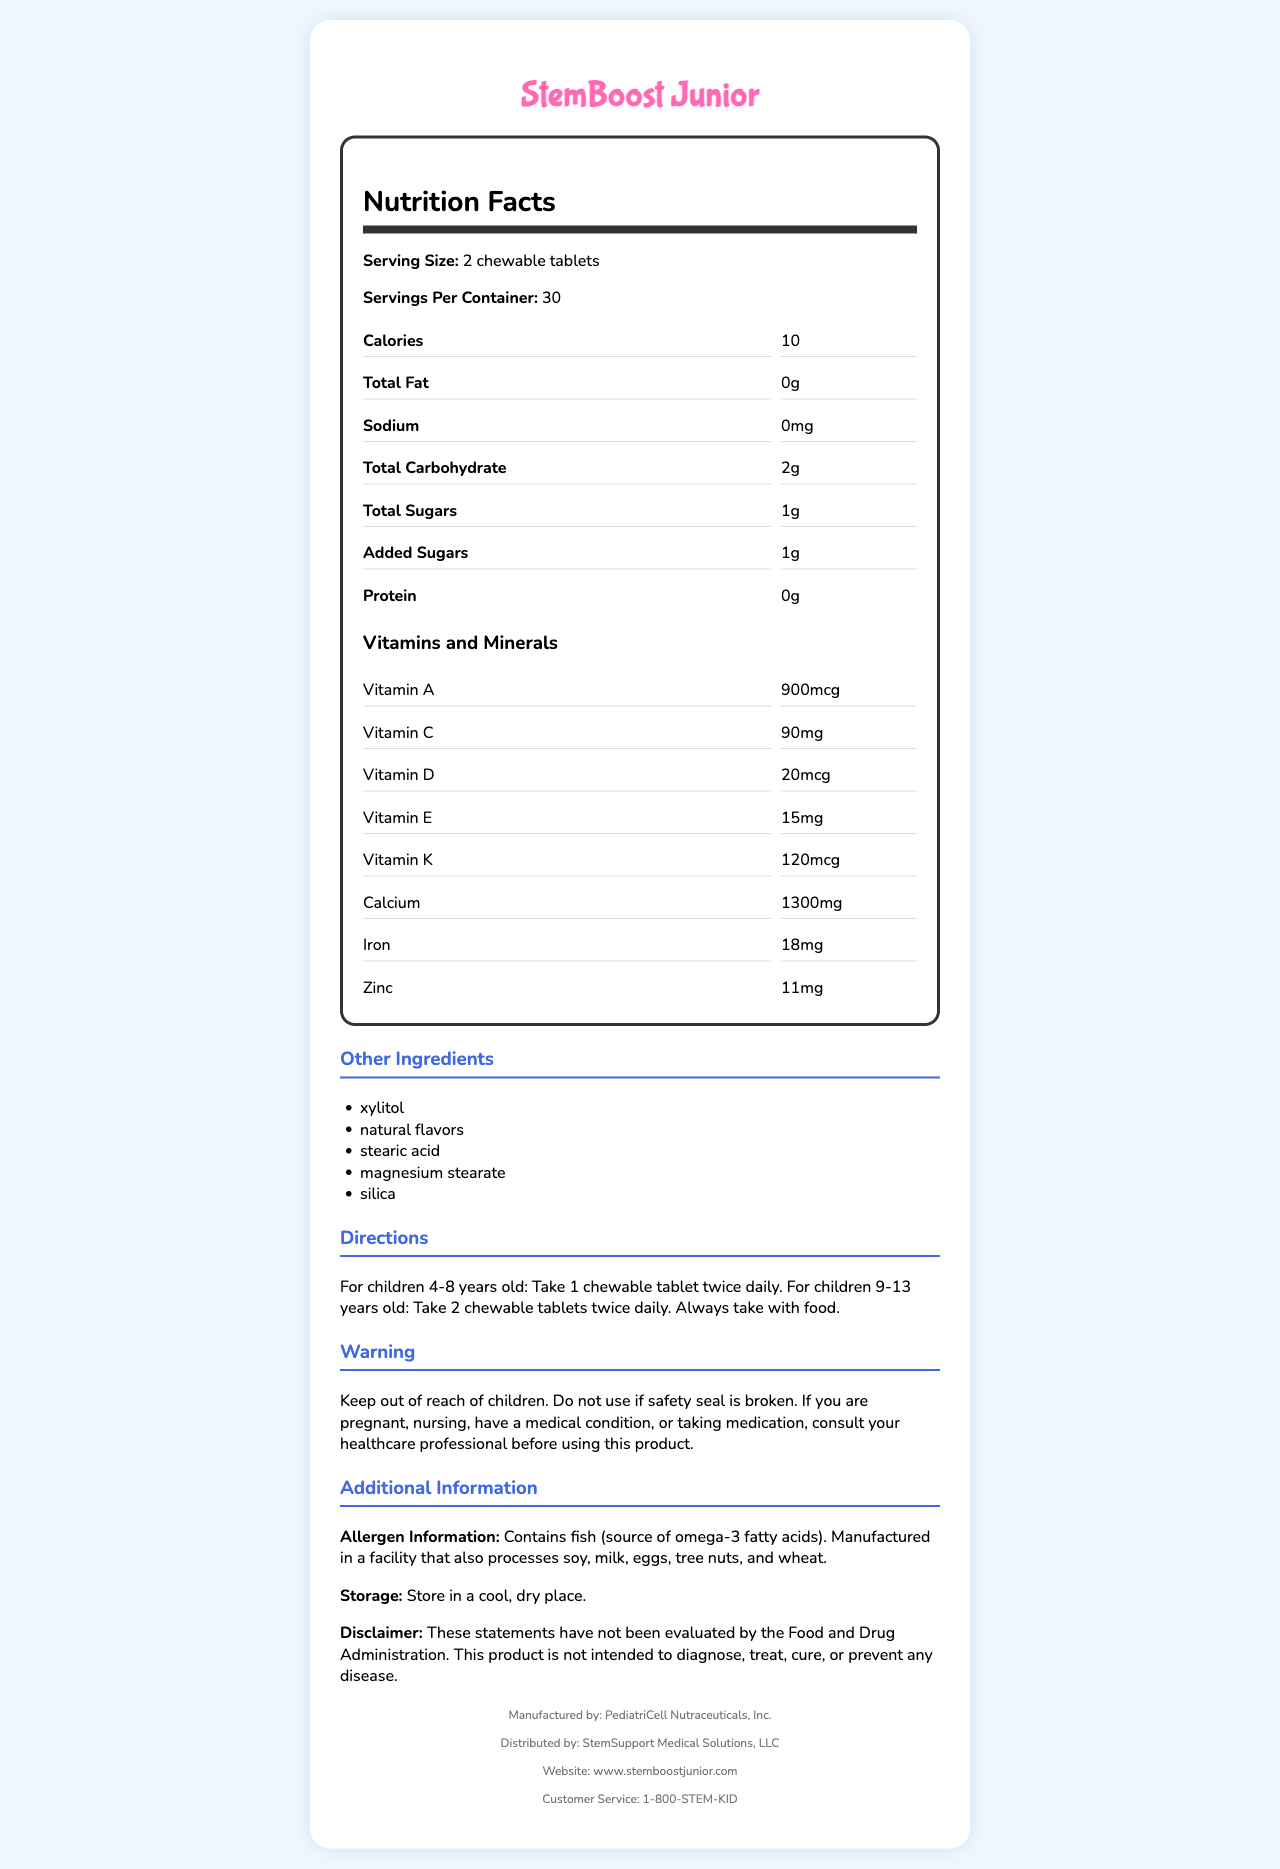what is the serving size for StemBoost Junior? The serving size is clearly stated as "2 chewable tablets" in the Nutrition Facts section.
Answer: 2 chewable tablets how many calories are in one serving of StemBoost Junior? The document specifies that there are 10 calories per serving.
Answer: 10 what age groups are provided with specific dosage directions? The Directions section specifies dosages for children 4-8 years old and children 9-13 years old.
Answer: Children 4-8 years old and children 9-13 years old what should you do if the safety seal is broken? The Warning section advises not to use the product if the safety seal is broken.
Answer: Do not use it how many servings are there per container? The Nutrition Facts section states that there are 30 servings per container.
Answer: 30 which of the following vitamins is included in StemBoost Junior? A. Vitamin H B. Vitamin K C. Vitamin X The Nutrition Facts section lists Vitamin K as one of the included vitamins.
Answer: B how much omega-3 fatty acids are in each serving? A. 50mg B. 100mg C. 200mg D. 150mg The document lists omega-3 fatty acids as containing 100mg per serving.
Answer: B is this product safe for children under 4 years old? The Directions section only provides guidelines for children 4-8 years old and 9-13 years old, implying it is not intended for children under 4 years old.
Answer: No does the product contain any allergens? The Allergen Information section states that the product contains fish and is manufactured in a facility that processes soy, milk, eggs, tree nuts, and wheat.
Answer: Yes summarize the main purpose of the document The document gives a comprehensive overview of the product "StemBoost Junior," including its nutritional content, serving size, dosage instructions, allergen information, warnings, and storage instructions.
Answer: Provide detailed nutrition facts and usage information for StemBoost Junior what is the source of omega-3 fatty acids in this supplement? The Allergen Information mentions that omega-3 fatty acids come from fish.
Answer: Fish is the product intended to diagnose, treat, cure, or prevent any disease? The Disclaimer explicitly states that the product is not intended to diagnose, treat, cure, or prevent any disease.
Answer: No how should the product be stored? The Storage section advises to store the product in a cool, dry place.
Answer: Store in a cool, dry place what are the main active ingredients in StemBoost Junior? The Nutrition Facts and Ingredients sections list vitamins, minerals, omega-3 fatty acids, L-carnitine, coenzyme Q10, inositol, and choline as main active ingredients.
Answer: Vitamins, minerals, omega-3 fatty acids, L-carnitine, coenzyme Q10, inositol, choline how should you take the tablets? The Directions section states that the tablets should always be taken with food.
Answer: Always take with food how do the vitamin D levels in StemBoost Junior compare to other children's supplements? The document does not provide any comparison with other children's supplements.
Answer: Cannot be determined 